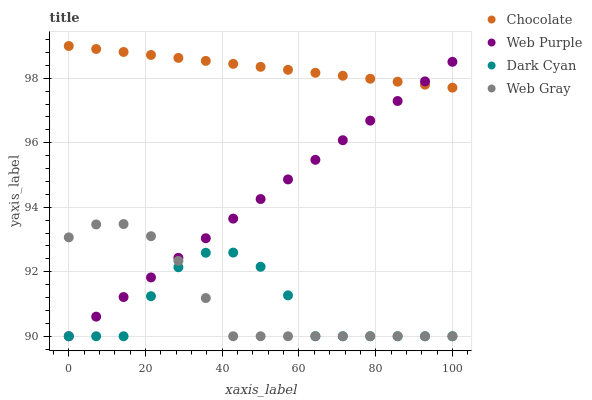Does Dark Cyan have the minimum area under the curve?
Answer yes or no. Yes. Does Chocolate have the maximum area under the curve?
Answer yes or no. Yes. Does Web Purple have the minimum area under the curve?
Answer yes or no. No. Does Web Purple have the maximum area under the curve?
Answer yes or no. No. Is Chocolate the smoothest?
Answer yes or no. Yes. Is Dark Cyan the roughest?
Answer yes or no. Yes. Is Web Purple the smoothest?
Answer yes or no. No. Is Web Purple the roughest?
Answer yes or no. No. Does Dark Cyan have the lowest value?
Answer yes or no. Yes. Does Chocolate have the lowest value?
Answer yes or no. No. Does Chocolate have the highest value?
Answer yes or no. Yes. Does Web Purple have the highest value?
Answer yes or no. No. Is Dark Cyan less than Chocolate?
Answer yes or no. Yes. Is Chocolate greater than Web Gray?
Answer yes or no. Yes. Does Chocolate intersect Web Purple?
Answer yes or no. Yes. Is Chocolate less than Web Purple?
Answer yes or no. No. Is Chocolate greater than Web Purple?
Answer yes or no. No. Does Dark Cyan intersect Chocolate?
Answer yes or no. No. 